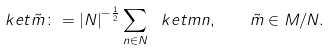Convert formula to latex. <formula><loc_0><loc_0><loc_500><loc_500>\ k e t { \tilde { m } } \colon = { | N | } ^ { - \frac { 1 } { 2 } } \sum _ { n \in N } \ k e t { m n } , \quad { \tilde { m } \in M / N } .</formula> 